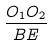Convert formula to latex. <formula><loc_0><loc_0><loc_500><loc_500>\frac { O _ { 1 } O _ { 2 } } { B E }</formula> 